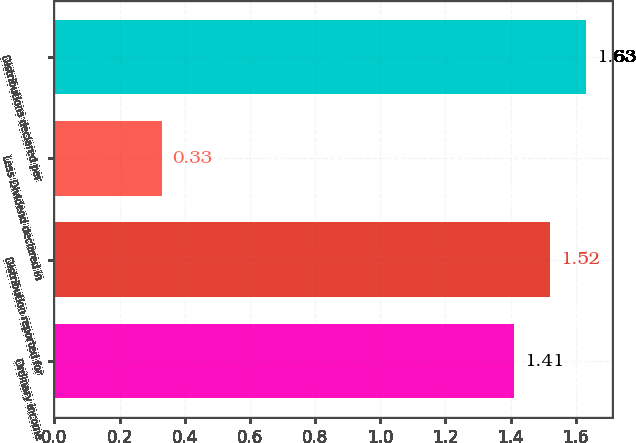<chart> <loc_0><loc_0><loc_500><loc_500><bar_chart><fcel>Ordinary income<fcel>Distribution reported for<fcel>Less Dividend declared in<fcel>Distributions declared per<nl><fcel>1.41<fcel>1.52<fcel>0.33<fcel>1.63<nl></chart> 